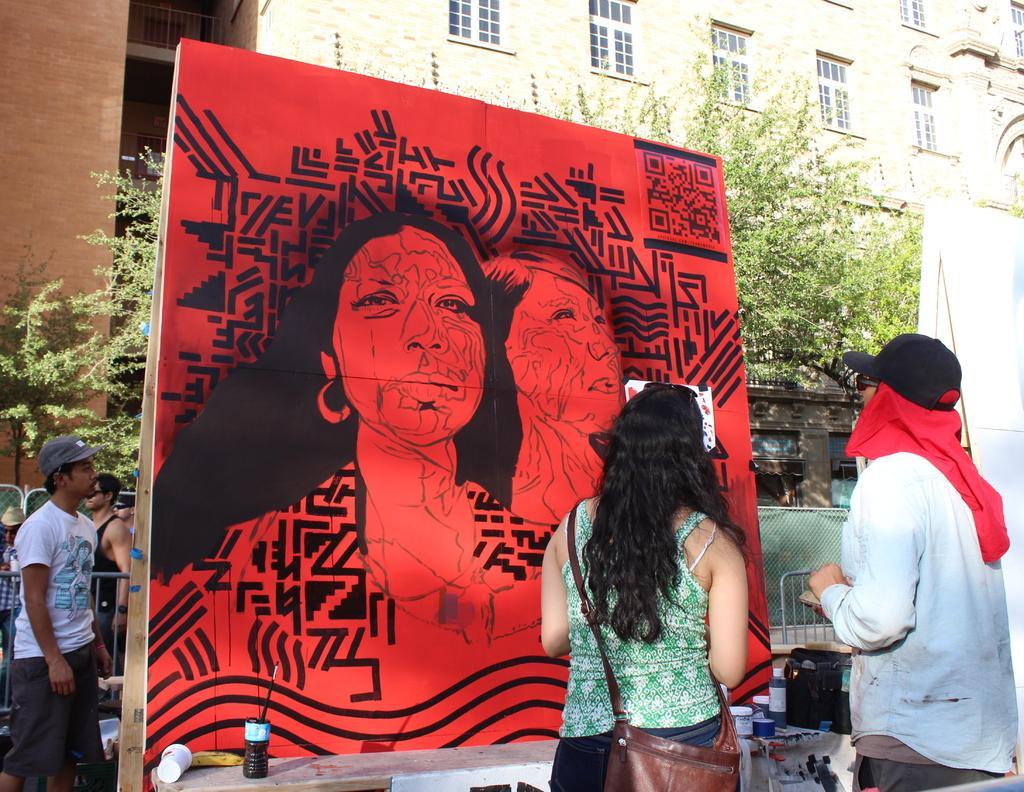Can you describe this image briefly? In this image I can see a hoarding board and I can see a red color painting visible on hoarding board, in front of the hoarding board I can see two persons at the top I can see the building and tree. on the left side I can see two persons and the wall. 